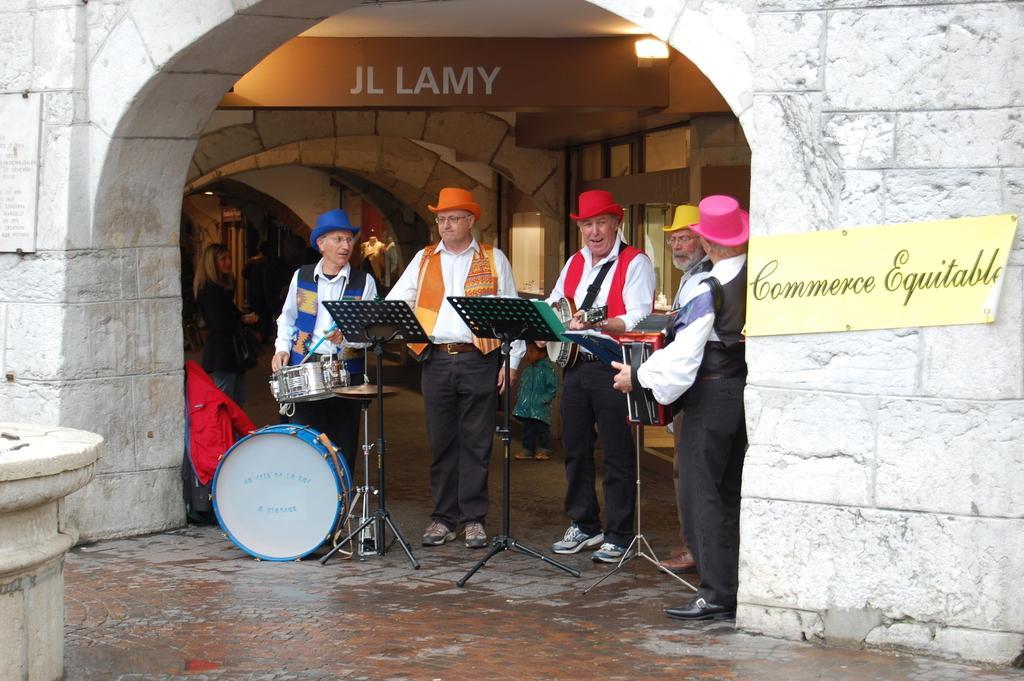In one or two sentences, can you explain what this image depicts? There is a group of people. They are playing a musical instruments. We can see in the background there is a arch and name board. 